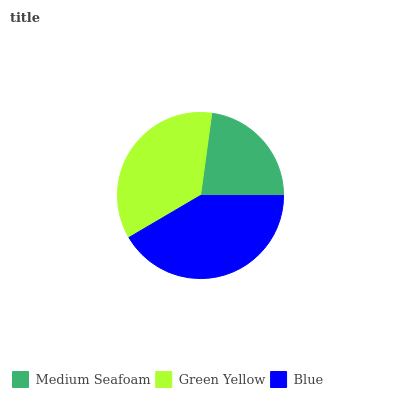Is Medium Seafoam the minimum?
Answer yes or no. Yes. Is Blue the maximum?
Answer yes or no. Yes. Is Green Yellow the minimum?
Answer yes or no. No. Is Green Yellow the maximum?
Answer yes or no. No. Is Green Yellow greater than Medium Seafoam?
Answer yes or no. Yes. Is Medium Seafoam less than Green Yellow?
Answer yes or no. Yes. Is Medium Seafoam greater than Green Yellow?
Answer yes or no. No. Is Green Yellow less than Medium Seafoam?
Answer yes or no. No. Is Green Yellow the high median?
Answer yes or no. Yes. Is Green Yellow the low median?
Answer yes or no. Yes. Is Blue the high median?
Answer yes or no. No. Is Medium Seafoam the low median?
Answer yes or no. No. 